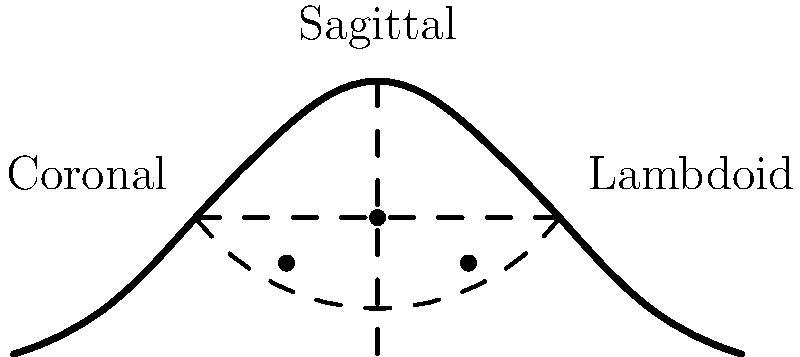Based on the skull suture closure diagram provided, which shows complete closure of the sagittal suture and partial closure of the coronal and lambdoid sutures, estimate the age range of the unidentified remains. Consider that suture closure typically follows a specific pattern and timing in human skull development. To estimate the age range from the skull suture closure diagram, we need to follow these steps:

1. Identify the closure status of each suture:
   - Sagittal suture: Completely closed
   - Coronal suture: Partially closed
   - Lambdoid suture: Partially closed

2. Understand the general pattern of suture closure:
   - Sagittal suture typically begins closing around age 22 and completes by age 35
   - Coronal suture begins closing around age 24 and completes by age 41
   - Lambdoid suture begins closing around age 26 and completes by age 47

3. Analyze the diagram:
   - The complete closure of the sagittal suture suggests an age of at least 35 years
   - Partial closure of coronal and lambdoid sutures indicates the process is ongoing but not complete

4. Estimate the age range:
   - Lower bound: 35 years (minimum age for complete sagittal closure)
   - Upper bound: Early to mid-40s, as coronal and lambdoid sutures are not fully closed

5. Consider individual variation:
   - Suture closure can vary between individuals and populations
   - A conservative estimate would widen the age range slightly

Based on this analysis, the estimated age range for the unidentified remains is approximately 35-45 years old.
Answer: 35-45 years old 